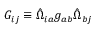Convert formula to latex. <formula><loc_0><loc_0><loc_500><loc_500>G _ { i j } \equiv \hat { \Omega } _ { i a } g _ { a b } \hat { \Omega } _ { b j }</formula> 